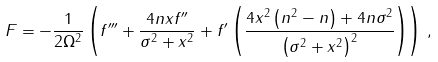<formula> <loc_0><loc_0><loc_500><loc_500>F = - \frac { 1 } { 2 \Omega ^ { 2 } } \left ( f ^ { \prime \prime \prime } + \frac { 4 n x f ^ { \prime \prime } } { \sigma ^ { 2 } + x ^ { 2 } } + f ^ { \prime } \left ( \frac { 4 x ^ { 2 } \left ( n ^ { 2 } - n \right ) + 4 n \sigma ^ { 2 } } { \left ( \sigma ^ { 2 } + x ^ { 2 } \right ) ^ { 2 } } \right ) \right ) \, ,</formula> 